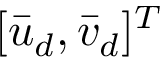<formula> <loc_0><loc_0><loc_500><loc_500>[ \bar { u } _ { d } , \bar { v } _ { d } ] ^ { T }</formula> 